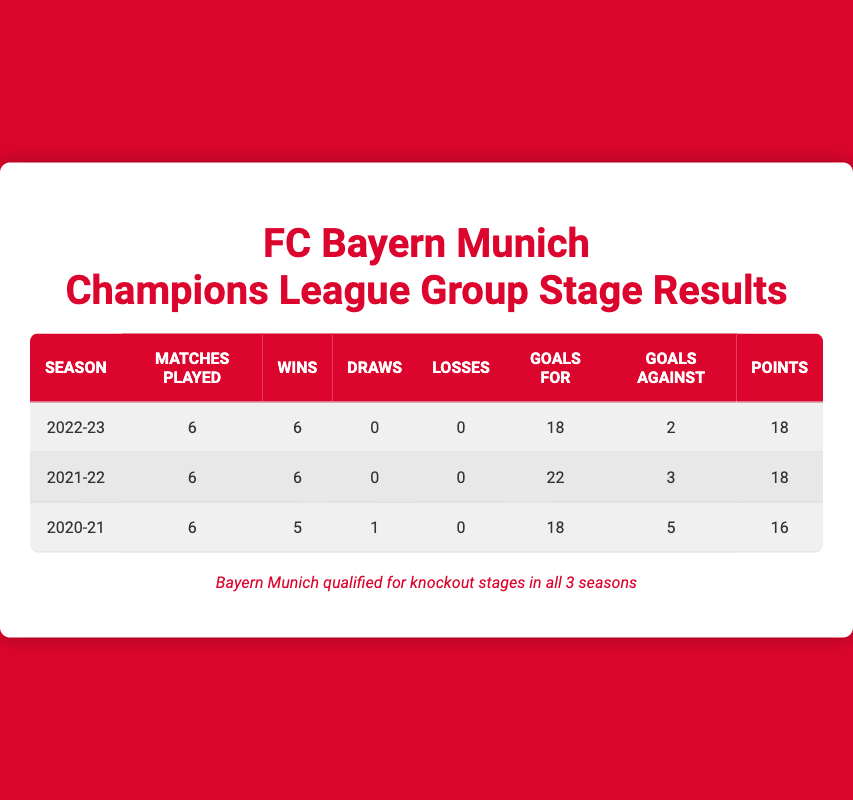What was Bayern Munich's performance in the 2022-23 Champions League group stage? Bayern Munich played 6 matches in the 2022-23 season, winning all 6, with no draws or losses. They scored 18 goals and conceded only 2, resulting in 18 points total.
Answer: They won all 6 matches How many goals did Bayern Munich score in total across the three seasons? To find the total goals scored, add the goals scored for each season: 18 (2022-23) + 22 (2021-22) + 18 (2020-21) = 58.
Answer: 58 goals Did Bayern Munich lose any matches during the 2021-22 season? According to the table, Bayern Munich did not lose any matches in the 2021-22 Champions League group stage; they won all 6 matches.
Answer: No Which season did Bayern Munich achieve the most goals conceded? Looking at the "Goals Against" column, the highest value is 5 goals in the 2020-21 season.
Answer: 2020-21 What is the average number of wins per season for Bayern Munich over the three years? The total wins over the three seasons is 6 (2022-23) + 6 (2021-22) + 5 (2020-21) = 17. Since there are 3 seasons, the average is 17 / 3 ≈ 5.67.
Answer: Approximately 5.67 wins In which season did Bayern Munich have the highest points total? By comparing the points across the three seasons: 18 (2022-23), 18 (2021-22), and 16 (2020-21), we see that the points total is highest in the first two seasons.
Answer: 2022-23 and 2021-22 What is the difference in total goals scored between the 2021-22 and 2020-21 seasons? Calculate the difference: 22 (2021-22) - 18 (2020-21) = 4 goals more in the 2021-22 season.
Answer: 4 goals Did Bayern Munich qualify for the knockout stages in all three seasons? The footnote states that Bayern Munich qualified for the knockout stages in all three seasons, confirming that this statement is true.
Answer: Yes 